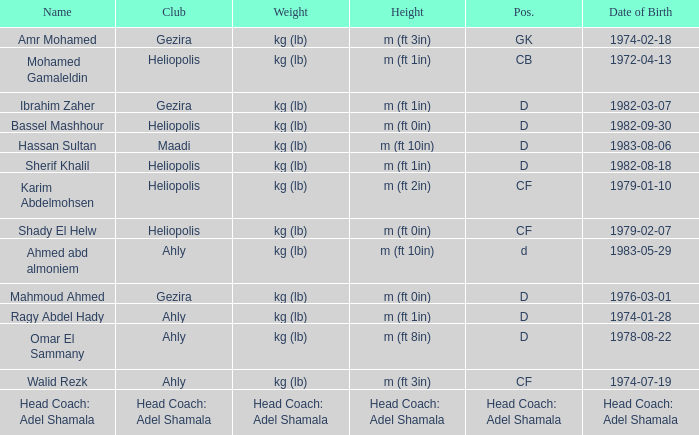What is Weight, when Club is "Maadi"? Kg (lb). 